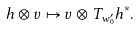<formula> <loc_0><loc_0><loc_500><loc_500>h \otimes v \mapsto v \otimes T _ { w _ { 0 } ^ { \prime } } h ^ { * } .</formula> 